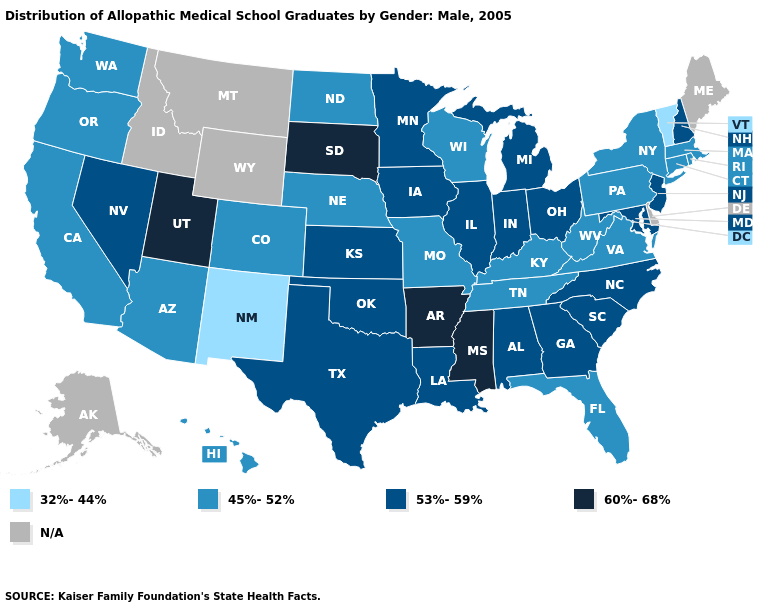Does the map have missing data?
Answer briefly. Yes. Among the states that border Alabama , does Georgia have the lowest value?
Quick response, please. No. Which states have the lowest value in the South?
Short answer required. Florida, Kentucky, Tennessee, Virginia, West Virginia. What is the value of Massachusetts?
Concise answer only. 45%-52%. Name the states that have a value in the range N/A?
Quick response, please. Alaska, Delaware, Idaho, Maine, Montana, Wyoming. What is the value of South Carolina?
Short answer required. 53%-59%. Does New Mexico have the lowest value in the USA?
Be succinct. Yes. Name the states that have a value in the range 53%-59%?
Give a very brief answer. Alabama, Georgia, Illinois, Indiana, Iowa, Kansas, Louisiana, Maryland, Michigan, Minnesota, Nevada, New Hampshire, New Jersey, North Carolina, Ohio, Oklahoma, South Carolina, Texas. How many symbols are there in the legend?
Answer briefly. 5. Does California have the highest value in the West?
Short answer required. No. Name the states that have a value in the range 60%-68%?
Concise answer only. Arkansas, Mississippi, South Dakota, Utah. Name the states that have a value in the range 45%-52%?
Short answer required. Arizona, California, Colorado, Connecticut, Florida, Hawaii, Kentucky, Massachusetts, Missouri, Nebraska, New York, North Dakota, Oregon, Pennsylvania, Rhode Island, Tennessee, Virginia, Washington, West Virginia, Wisconsin. What is the value of Pennsylvania?
Give a very brief answer. 45%-52%. 